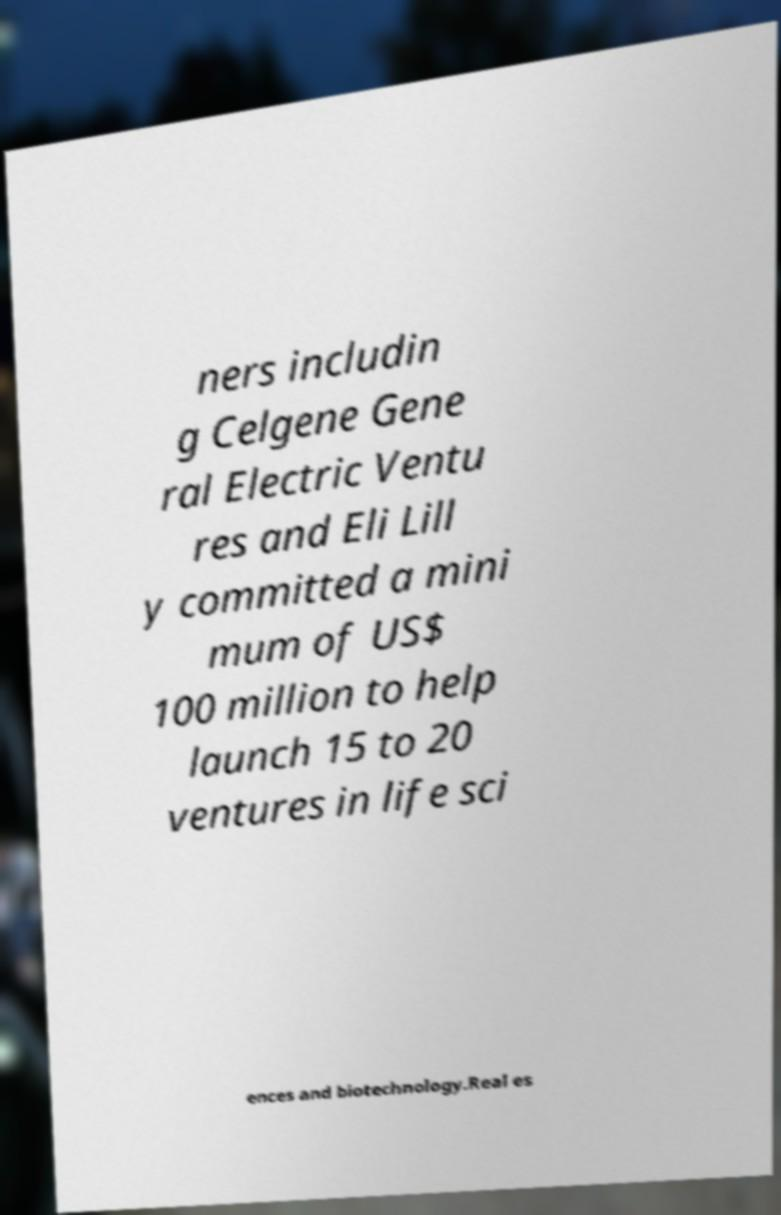Please read and relay the text visible in this image. What does it say? ners includin g Celgene Gene ral Electric Ventu res and Eli Lill y committed a mini mum of US$ 100 million to help launch 15 to 20 ventures in life sci ences and biotechnology.Real es 